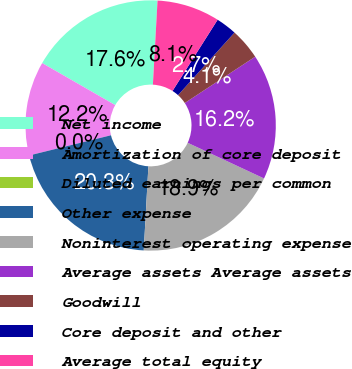Convert chart to OTSL. <chart><loc_0><loc_0><loc_500><loc_500><pie_chart><fcel>Net income<fcel>Amortization of core deposit<fcel>Diluted earnings per common<fcel>Other expense<fcel>Noninterest operating expense<fcel>Average assets Average assets<fcel>Goodwill<fcel>Core deposit and other<fcel>Average total equity<nl><fcel>17.57%<fcel>12.16%<fcel>0.0%<fcel>20.27%<fcel>18.92%<fcel>16.22%<fcel>4.05%<fcel>2.7%<fcel>8.11%<nl></chart> 